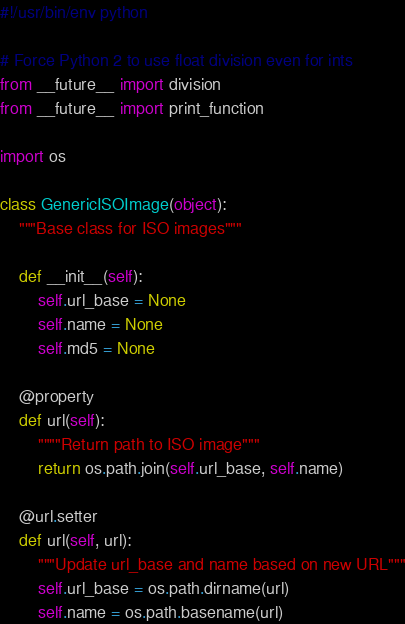<code> <loc_0><loc_0><loc_500><loc_500><_Python_>#!/usr/bin/env python

# Force Python 2 to use float division even for ints
from __future__ import division
from __future__ import print_function

import os

class GenericISOImage(object):
    """Base class for ISO images"""

    def __init__(self):
        self.url_base = None
        self.name = None
        self.md5 = None

    @property
    def url(self):
        """"Return path to ISO image"""
        return os.path.join(self.url_base, self.name)

    @url.setter
    def url(self, url):
        """Update url_base and name based on new URL"""
        self.url_base = os.path.dirname(url)
        self.name = os.path.basename(url)
</code> 